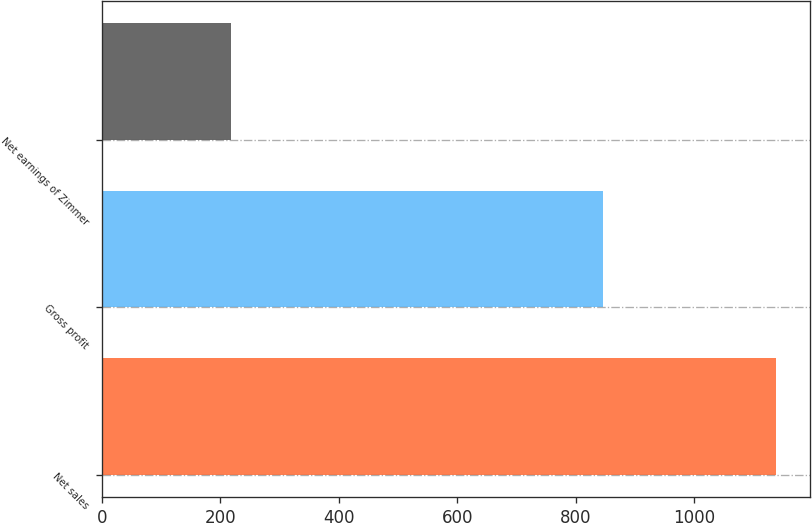<chart> <loc_0><loc_0><loc_500><loc_500><bar_chart><fcel>Net sales<fcel>Gross profit<fcel>Net earnings of Zimmer<nl><fcel>1138.9<fcel>846<fcel>218.6<nl></chart> 